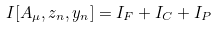<formula> <loc_0><loc_0><loc_500><loc_500>I [ A _ { \mu } , z _ { n } , y _ { n } ] = I _ { F } + I _ { C } + I _ { P }</formula> 